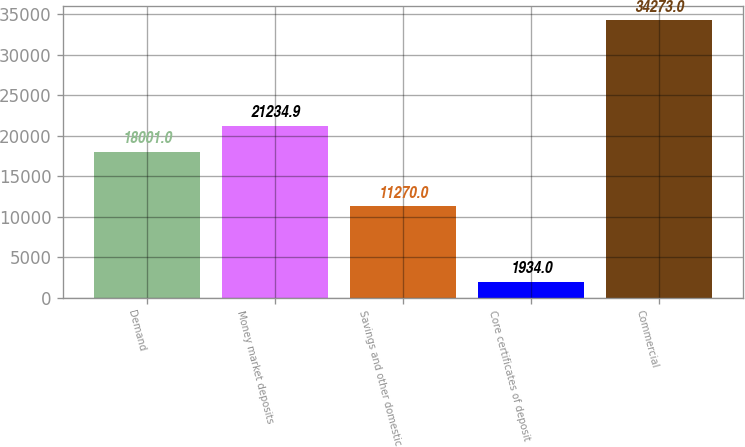<chart> <loc_0><loc_0><loc_500><loc_500><bar_chart><fcel>Demand<fcel>Money market deposits<fcel>Savings and other domestic<fcel>Core certificates of deposit<fcel>Commercial<nl><fcel>18001<fcel>21234.9<fcel>11270<fcel>1934<fcel>34273<nl></chart> 